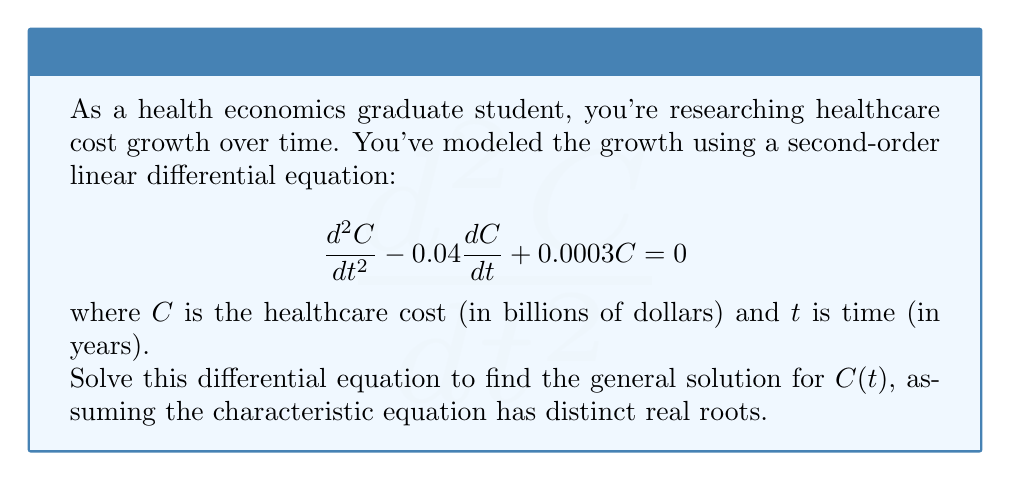Could you help me with this problem? To solve this second-order linear differential equation, we'll follow these steps:

1) First, we need to find the characteristic equation. For a differential equation in the form:
   $$a\frac{d^2C}{dt^2} + b\frac{dC}{dt} + cC = 0$$
   The characteristic equation is:
   $$ar^2 + br + c = 0$$

2) In our case, $a=1$, $b=-0.04$, and $c=0.0003$. So our characteristic equation is:
   $$r^2 - 0.04r + 0.0003 = 0$$

3) We can solve this quadratic equation using the quadratic formula:
   $$r = \frac{-b \pm \sqrt{b^2 - 4ac}}{2a}$$

4) Substituting our values:
   $$r = \frac{0.04 \pm \sqrt{(-0.04)^2 - 4(1)(0.0003)}}{2(1)}$$
   $$= \frac{0.04 \pm \sqrt{0.0016 - 0.0012}}{2}$$
   $$= \frac{0.04 \pm \sqrt{0.0004}}{2}$$
   $$= \frac{0.04 \pm 0.02}{2}$$

5) This gives us two distinct real roots:
   $$r_1 = \frac{0.04 + 0.02}{2} = 0.03$$
   $$r_2 = \frac{0.04 - 0.02}{2} = 0.01$$

6) The general solution for a second-order linear differential equation with distinct real roots is:
   $$C(t) = c_1e^{r_1t} + c_2e^{r_2t}$$

7) Substituting our roots:
   $$C(t) = c_1e^{0.03t} + c_2e^{0.01t}$$

Where $c_1$ and $c_2$ are arbitrary constants that would be determined by initial conditions.
Answer: $C(t) = c_1e^{0.03t} + c_2e^{0.01t}$ 